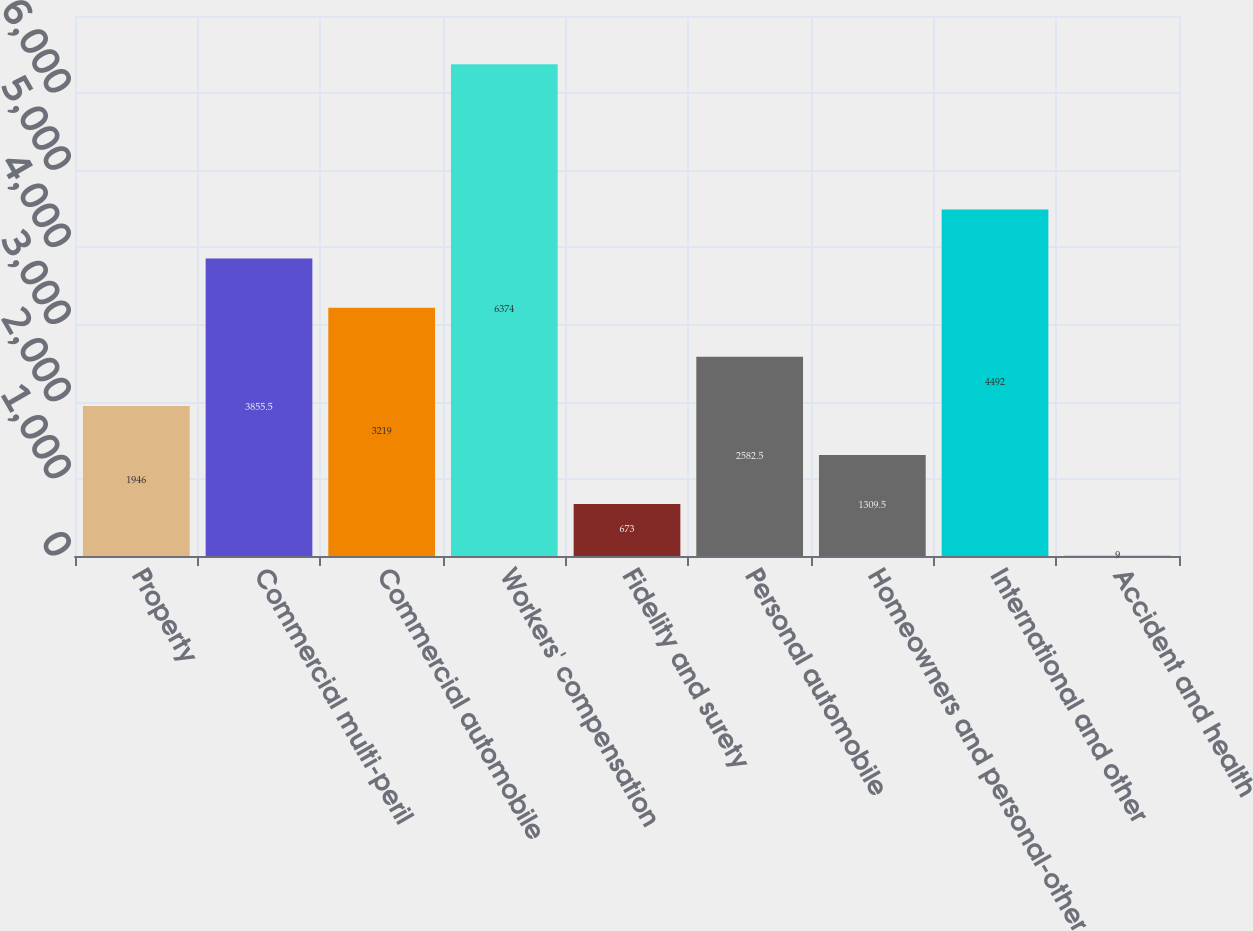Convert chart to OTSL. <chart><loc_0><loc_0><loc_500><loc_500><bar_chart><fcel>Property<fcel>Commercial multi-peril<fcel>Commercial automobile<fcel>Workers' compensation<fcel>Fidelity and surety<fcel>Personal automobile<fcel>Homeowners and personal-other<fcel>International and other<fcel>Accident and health<nl><fcel>1946<fcel>3855.5<fcel>3219<fcel>6374<fcel>673<fcel>2582.5<fcel>1309.5<fcel>4492<fcel>9<nl></chart> 